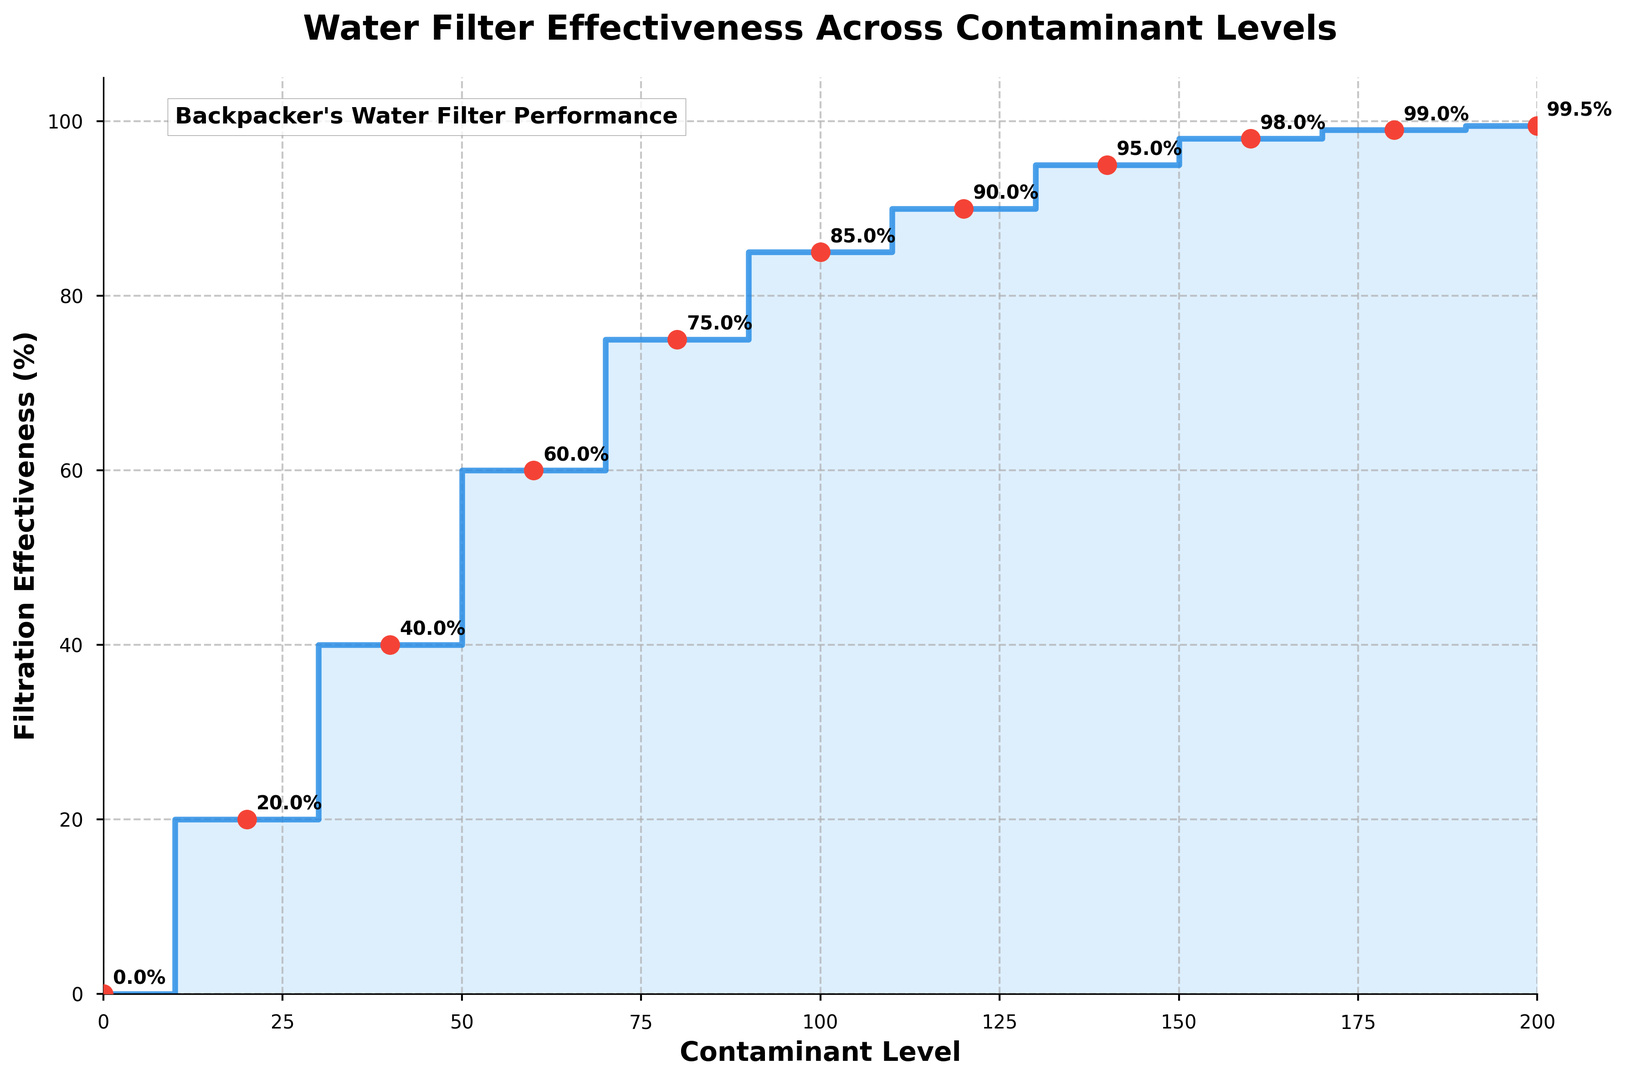What is the filtration effectiveness at a contaminant level of 50? Locate the contaminant level of 50 on the x-axis and follow the vertical line up to the stairs plot. The corresponding y-value should be noted as the filtration effectiveness.
Answer: 60% Does the filtration effectiveness change between contaminant levels of 10 and 20? Observe the y-values at contaminant levels 10 and 20. Both levels have a filtration effectiveness of 20%, indicating no change between these two points.
Answer: No At which contaminant levels does the filtration effectiveness reach 95%? Look for the points on the plot where the y-value is 95%. These points are at contaminant levels of 130 and 140.
Answer: 130 and 140 What is the difference in filtration effectiveness between contaminant levels of 160 and 190? Locate the filtration effectiveness values at contaminant levels 160 (98%) and 190 (99.5%). Subtract the former from the latter to find the difference.
Answer: 1.5% How many steps are there where the filtration effectiveness does not change? Count the number of horizontal lines (where the y-value remains constant) in the stairs plot. These horizontal segments indicate no change in effectiveness.
Answer: 8 steps Which contaminant level shows the most significant jump in filtration effectiveness? Identify the longest vertical segment in the stairs plot by comparing the lengths of the jumps between successive points. The jump from contaminant level 40 to 50 has the largest increase (20%).
Answer: Between 40 and 50 At a contaminant level of 90, what is the filtration effectiveness, and how does it compare to the effectiveness at a level of 150? Check the y-values at contaminant levels 90 (85%) and 150 (98%). Compare these values directly.
Answer: 85%, 13% less than at 150 What can be inferred about the filtration effectiveness trend as contaminant level increases from 0 to 200? Observe the overall trend in the stairs plot, noting that the filtration effectiveness generally increases with contaminant level but stabilizes at several points with incremental improvements.
Answer: Increases with levels but stabilizes periodically At which contaminant levels does the filtration effectiveness remain the same for multiple steps, and what are the values? Identify the horizontal sections of the stairs plot and note the x-values where the y-values stay consistent for consecutive steps. They occur at 10-20 (20%), 30-40 (40%), 50-60 (60%), 70-80 (75%), 90-100 (85%), 110-120 (90%), 130-140 (95%), 150-160 (98%), and 170-190 (99%).
Answer: Multiple, refer detailed explanation What is the visual indicator used to highlight key points on the plot? Observe the plot's visual elements; key points are highlighted using red scatter markers and annotations indicating the filtration effectiveness in percentage.
Answer: Red markers and annotations 